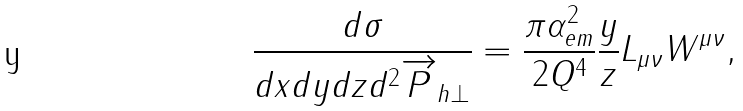<formula> <loc_0><loc_0><loc_500><loc_500>\frac { d \sigma } { d x d y d z d ^ { 2 } \overrightarrow { P } _ { h \bot } } = \frac { \pi \alpha _ { e m } ^ { 2 } } { 2 Q ^ { 4 } } \frac { y } { z } L _ { \mu \nu } W ^ { \mu \nu } ,</formula> 